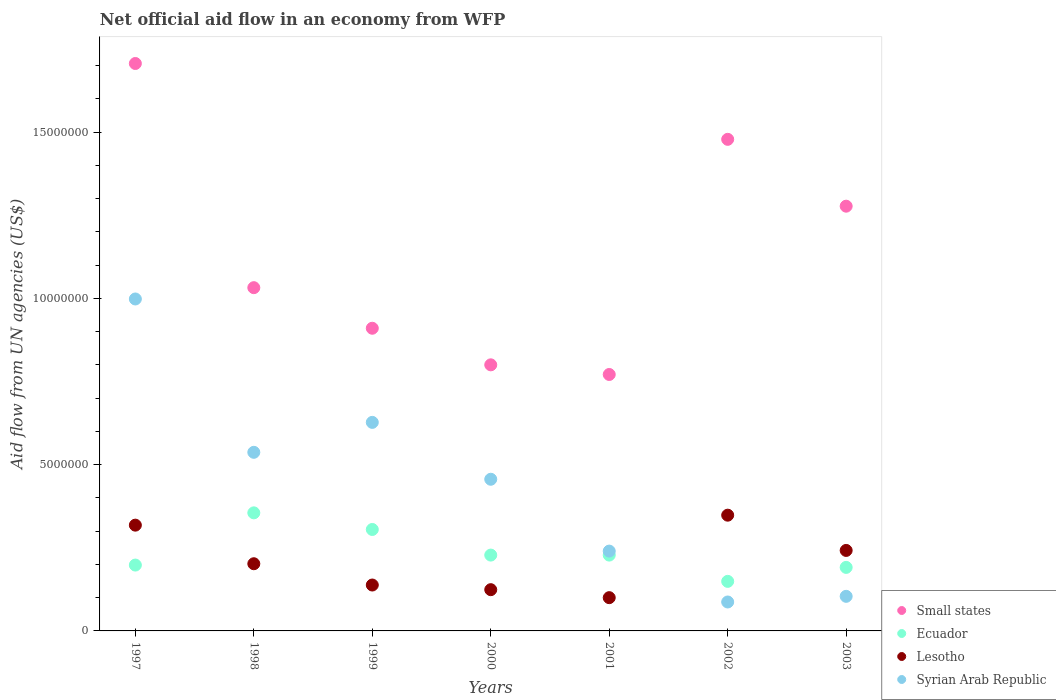How many different coloured dotlines are there?
Make the answer very short. 4. Is the number of dotlines equal to the number of legend labels?
Ensure brevity in your answer.  Yes. What is the net official aid flow in Lesotho in 2000?
Give a very brief answer. 1.24e+06. Across all years, what is the maximum net official aid flow in Small states?
Offer a terse response. 1.71e+07. Across all years, what is the minimum net official aid flow in Syrian Arab Republic?
Your answer should be very brief. 8.70e+05. What is the total net official aid flow in Ecuador in the graph?
Offer a terse response. 1.65e+07. What is the difference between the net official aid flow in Ecuador in 1998 and that in 1999?
Ensure brevity in your answer.  5.00e+05. What is the difference between the net official aid flow in Small states in 1997 and the net official aid flow in Lesotho in 2001?
Ensure brevity in your answer.  1.61e+07. What is the average net official aid flow in Syrian Arab Republic per year?
Ensure brevity in your answer.  4.36e+06. In the year 1998, what is the difference between the net official aid flow in Syrian Arab Republic and net official aid flow in Ecuador?
Offer a terse response. 1.82e+06. In how many years, is the net official aid flow in Syrian Arab Republic greater than 14000000 US$?
Ensure brevity in your answer.  0. What is the ratio of the net official aid flow in Small states in 2001 to that in 2002?
Ensure brevity in your answer.  0.52. Is the net official aid flow in Syrian Arab Republic in 1998 less than that in 2003?
Your answer should be very brief. No. Is the difference between the net official aid flow in Syrian Arab Republic in 1998 and 2000 greater than the difference between the net official aid flow in Ecuador in 1998 and 2000?
Your answer should be very brief. No. What is the difference between the highest and the second highest net official aid flow in Syrian Arab Republic?
Offer a terse response. 3.71e+06. What is the difference between the highest and the lowest net official aid flow in Ecuador?
Offer a terse response. 2.06e+06. In how many years, is the net official aid flow in Lesotho greater than the average net official aid flow in Lesotho taken over all years?
Offer a terse response. 3. Is it the case that in every year, the sum of the net official aid flow in Lesotho and net official aid flow in Ecuador  is greater than the net official aid flow in Syrian Arab Republic?
Provide a succinct answer. No. Does the net official aid flow in Syrian Arab Republic monotonically increase over the years?
Ensure brevity in your answer.  No. Is the net official aid flow in Small states strictly greater than the net official aid flow in Lesotho over the years?
Your answer should be very brief. Yes. Is the net official aid flow in Syrian Arab Republic strictly less than the net official aid flow in Ecuador over the years?
Provide a short and direct response. No. How many dotlines are there?
Offer a very short reply. 4. How many years are there in the graph?
Ensure brevity in your answer.  7. Does the graph contain grids?
Keep it short and to the point. No. What is the title of the graph?
Your answer should be compact. Net official aid flow in an economy from WFP. What is the label or title of the Y-axis?
Make the answer very short. Aid flow from UN agencies (US$). What is the Aid flow from UN agencies (US$) of Small states in 1997?
Make the answer very short. 1.71e+07. What is the Aid flow from UN agencies (US$) of Ecuador in 1997?
Offer a terse response. 1.98e+06. What is the Aid flow from UN agencies (US$) in Lesotho in 1997?
Keep it short and to the point. 3.18e+06. What is the Aid flow from UN agencies (US$) in Syrian Arab Republic in 1997?
Your answer should be very brief. 9.98e+06. What is the Aid flow from UN agencies (US$) in Small states in 1998?
Your response must be concise. 1.03e+07. What is the Aid flow from UN agencies (US$) of Ecuador in 1998?
Provide a succinct answer. 3.55e+06. What is the Aid flow from UN agencies (US$) of Lesotho in 1998?
Offer a very short reply. 2.02e+06. What is the Aid flow from UN agencies (US$) of Syrian Arab Republic in 1998?
Provide a short and direct response. 5.37e+06. What is the Aid flow from UN agencies (US$) of Small states in 1999?
Keep it short and to the point. 9.10e+06. What is the Aid flow from UN agencies (US$) of Ecuador in 1999?
Keep it short and to the point. 3.05e+06. What is the Aid flow from UN agencies (US$) of Lesotho in 1999?
Your answer should be compact. 1.38e+06. What is the Aid flow from UN agencies (US$) in Syrian Arab Republic in 1999?
Offer a terse response. 6.27e+06. What is the Aid flow from UN agencies (US$) in Ecuador in 2000?
Provide a short and direct response. 2.28e+06. What is the Aid flow from UN agencies (US$) in Lesotho in 2000?
Your answer should be compact. 1.24e+06. What is the Aid flow from UN agencies (US$) in Syrian Arab Republic in 2000?
Your answer should be very brief. 4.56e+06. What is the Aid flow from UN agencies (US$) in Small states in 2001?
Your response must be concise. 7.71e+06. What is the Aid flow from UN agencies (US$) in Ecuador in 2001?
Give a very brief answer. 2.28e+06. What is the Aid flow from UN agencies (US$) of Lesotho in 2001?
Your response must be concise. 1.00e+06. What is the Aid flow from UN agencies (US$) of Syrian Arab Republic in 2001?
Offer a very short reply. 2.40e+06. What is the Aid flow from UN agencies (US$) in Small states in 2002?
Your answer should be very brief. 1.48e+07. What is the Aid flow from UN agencies (US$) of Ecuador in 2002?
Your response must be concise. 1.49e+06. What is the Aid flow from UN agencies (US$) of Lesotho in 2002?
Provide a short and direct response. 3.48e+06. What is the Aid flow from UN agencies (US$) in Syrian Arab Republic in 2002?
Provide a succinct answer. 8.70e+05. What is the Aid flow from UN agencies (US$) of Small states in 2003?
Give a very brief answer. 1.28e+07. What is the Aid flow from UN agencies (US$) of Ecuador in 2003?
Offer a terse response. 1.91e+06. What is the Aid flow from UN agencies (US$) in Lesotho in 2003?
Make the answer very short. 2.42e+06. What is the Aid flow from UN agencies (US$) of Syrian Arab Republic in 2003?
Offer a very short reply. 1.04e+06. Across all years, what is the maximum Aid flow from UN agencies (US$) of Small states?
Give a very brief answer. 1.71e+07. Across all years, what is the maximum Aid flow from UN agencies (US$) of Ecuador?
Offer a very short reply. 3.55e+06. Across all years, what is the maximum Aid flow from UN agencies (US$) of Lesotho?
Give a very brief answer. 3.48e+06. Across all years, what is the maximum Aid flow from UN agencies (US$) of Syrian Arab Republic?
Provide a short and direct response. 9.98e+06. Across all years, what is the minimum Aid flow from UN agencies (US$) of Small states?
Provide a short and direct response. 7.71e+06. Across all years, what is the minimum Aid flow from UN agencies (US$) of Ecuador?
Provide a short and direct response. 1.49e+06. Across all years, what is the minimum Aid flow from UN agencies (US$) in Syrian Arab Republic?
Your response must be concise. 8.70e+05. What is the total Aid flow from UN agencies (US$) of Small states in the graph?
Ensure brevity in your answer.  7.97e+07. What is the total Aid flow from UN agencies (US$) in Ecuador in the graph?
Your answer should be compact. 1.65e+07. What is the total Aid flow from UN agencies (US$) in Lesotho in the graph?
Ensure brevity in your answer.  1.47e+07. What is the total Aid flow from UN agencies (US$) of Syrian Arab Republic in the graph?
Your response must be concise. 3.05e+07. What is the difference between the Aid flow from UN agencies (US$) in Small states in 1997 and that in 1998?
Your answer should be very brief. 6.74e+06. What is the difference between the Aid flow from UN agencies (US$) in Ecuador in 1997 and that in 1998?
Your answer should be compact. -1.57e+06. What is the difference between the Aid flow from UN agencies (US$) in Lesotho in 1997 and that in 1998?
Provide a short and direct response. 1.16e+06. What is the difference between the Aid flow from UN agencies (US$) of Syrian Arab Republic in 1997 and that in 1998?
Your answer should be very brief. 4.61e+06. What is the difference between the Aid flow from UN agencies (US$) in Small states in 1997 and that in 1999?
Ensure brevity in your answer.  7.96e+06. What is the difference between the Aid flow from UN agencies (US$) of Ecuador in 1997 and that in 1999?
Give a very brief answer. -1.07e+06. What is the difference between the Aid flow from UN agencies (US$) of Lesotho in 1997 and that in 1999?
Make the answer very short. 1.80e+06. What is the difference between the Aid flow from UN agencies (US$) of Syrian Arab Republic in 1997 and that in 1999?
Ensure brevity in your answer.  3.71e+06. What is the difference between the Aid flow from UN agencies (US$) of Small states in 1997 and that in 2000?
Offer a terse response. 9.06e+06. What is the difference between the Aid flow from UN agencies (US$) of Lesotho in 1997 and that in 2000?
Provide a short and direct response. 1.94e+06. What is the difference between the Aid flow from UN agencies (US$) in Syrian Arab Republic in 1997 and that in 2000?
Offer a terse response. 5.42e+06. What is the difference between the Aid flow from UN agencies (US$) in Small states in 1997 and that in 2001?
Your answer should be very brief. 9.35e+06. What is the difference between the Aid flow from UN agencies (US$) of Lesotho in 1997 and that in 2001?
Give a very brief answer. 2.18e+06. What is the difference between the Aid flow from UN agencies (US$) of Syrian Arab Republic in 1997 and that in 2001?
Provide a succinct answer. 7.58e+06. What is the difference between the Aid flow from UN agencies (US$) of Small states in 1997 and that in 2002?
Provide a succinct answer. 2.28e+06. What is the difference between the Aid flow from UN agencies (US$) in Ecuador in 1997 and that in 2002?
Ensure brevity in your answer.  4.90e+05. What is the difference between the Aid flow from UN agencies (US$) of Syrian Arab Republic in 1997 and that in 2002?
Provide a short and direct response. 9.11e+06. What is the difference between the Aid flow from UN agencies (US$) of Small states in 1997 and that in 2003?
Your answer should be compact. 4.29e+06. What is the difference between the Aid flow from UN agencies (US$) of Lesotho in 1997 and that in 2003?
Your answer should be compact. 7.60e+05. What is the difference between the Aid flow from UN agencies (US$) in Syrian Arab Republic in 1997 and that in 2003?
Your response must be concise. 8.94e+06. What is the difference between the Aid flow from UN agencies (US$) in Small states in 1998 and that in 1999?
Offer a very short reply. 1.22e+06. What is the difference between the Aid flow from UN agencies (US$) of Ecuador in 1998 and that in 1999?
Your answer should be compact. 5.00e+05. What is the difference between the Aid flow from UN agencies (US$) in Lesotho in 1998 and that in 1999?
Provide a succinct answer. 6.40e+05. What is the difference between the Aid flow from UN agencies (US$) of Syrian Arab Republic in 1998 and that in 1999?
Offer a terse response. -9.00e+05. What is the difference between the Aid flow from UN agencies (US$) of Small states in 1998 and that in 2000?
Give a very brief answer. 2.32e+06. What is the difference between the Aid flow from UN agencies (US$) in Ecuador in 1998 and that in 2000?
Make the answer very short. 1.27e+06. What is the difference between the Aid flow from UN agencies (US$) in Lesotho in 1998 and that in 2000?
Offer a very short reply. 7.80e+05. What is the difference between the Aid flow from UN agencies (US$) in Syrian Arab Republic in 1998 and that in 2000?
Offer a terse response. 8.10e+05. What is the difference between the Aid flow from UN agencies (US$) of Small states in 1998 and that in 2001?
Your answer should be very brief. 2.61e+06. What is the difference between the Aid flow from UN agencies (US$) of Ecuador in 1998 and that in 2001?
Provide a short and direct response. 1.27e+06. What is the difference between the Aid flow from UN agencies (US$) in Lesotho in 1998 and that in 2001?
Your response must be concise. 1.02e+06. What is the difference between the Aid flow from UN agencies (US$) in Syrian Arab Republic in 1998 and that in 2001?
Offer a very short reply. 2.97e+06. What is the difference between the Aid flow from UN agencies (US$) in Small states in 1998 and that in 2002?
Provide a short and direct response. -4.46e+06. What is the difference between the Aid flow from UN agencies (US$) of Ecuador in 1998 and that in 2002?
Provide a short and direct response. 2.06e+06. What is the difference between the Aid flow from UN agencies (US$) in Lesotho in 1998 and that in 2002?
Provide a succinct answer. -1.46e+06. What is the difference between the Aid flow from UN agencies (US$) of Syrian Arab Republic in 1998 and that in 2002?
Your answer should be compact. 4.50e+06. What is the difference between the Aid flow from UN agencies (US$) in Small states in 1998 and that in 2003?
Your response must be concise. -2.45e+06. What is the difference between the Aid flow from UN agencies (US$) in Ecuador in 1998 and that in 2003?
Your answer should be very brief. 1.64e+06. What is the difference between the Aid flow from UN agencies (US$) of Lesotho in 1998 and that in 2003?
Make the answer very short. -4.00e+05. What is the difference between the Aid flow from UN agencies (US$) in Syrian Arab Republic in 1998 and that in 2003?
Ensure brevity in your answer.  4.33e+06. What is the difference between the Aid flow from UN agencies (US$) in Small states in 1999 and that in 2000?
Keep it short and to the point. 1.10e+06. What is the difference between the Aid flow from UN agencies (US$) in Ecuador in 1999 and that in 2000?
Provide a short and direct response. 7.70e+05. What is the difference between the Aid flow from UN agencies (US$) of Lesotho in 1999 and that in 2000?
Your answer should be compact. 1.40e+05. What is the difference between the Aid flow from UN agencies (US$) in Syrian Arab Republic in 1999 and that in 2000?
Ensure brevity in your answer.  1.71e+06. What is the difference between the Aid flow from UN agencies (US$) in Small states in 1999 and that in 2001?
Provide a succinct answer. 1.39e+06. What is the difference between the Aid flow from UN agencies (US$) of Ecuador in 1999 and that in 2001?
Provide a short and direct response. 7.70e+05. What is the difference between the Aid flow from UN agencies (US$) of Lesotho in 1999 and that in 2001?
Offer a very short reply. 3.80e+05. What is the difference between the Aid flow from UN agencies (US$) in Syrian Arab Republic in 1999 and that in 2001?
Your answer should be compact. 3.87e+06. What is the difference between the Aid flow from UN agencies (US$) in Small states in 1999 and that in 2002?
Your answer should be very brief. -5.68e+06. What is the difference between the Aid flow from UN agencies (US$) of Ecuador in 1999 and that in 2002?
Give a very brief answer. 1.56e+06. What is the difference between the Aid flow from UN agencies (US$) of Lesotho in 1999 and that in 2002?
Give a very brief answer. -2.10e+06. What is the difference between the Aid flow from UN agencies (US$) in Syrian Arab Republic in 1999 and that in 2002?
Your answer should be compact. 5.40e+06. What is the difference between the Aid flow from UN agencies (US$) in Small states in 1999 and that in 2003?
Your response must be concise. -3.67e+06. What is the difference between the Aid flow from UN agencies (US$) in Ecuador in 1999 and that in 2003?
Your response must be concise. 1.14e+06. What is the difference between the Aid flow from UN agencies (US$) in Lesotho in 1999 and that in 2003?
Your response must be concise. -1.04e+06. What is the difference between the Aid flow from UN agencies (US$) in Syrian Arab Republic in 1999 and that in 2003?
Make the answer very short. 5.23e+06. What is the difference between the Aid flow from UN agencies (US$) of Lesotho in 2000 and that in 2001?
Ensure brevity in your answer.  2.40e+05. What is the difference between the Aid flow from UN agencies (US$) in Syrian Arab Republic in 2000 and that in 2001?
Provide a succinct answer. 2.16e+06. What is the difference between the Aid flow from UN agencies (US$) in Small states in 2000 and that in 2002?
Make the answer very short. -6.78e+06. What is the difference between the Aid flow from UN agencies (US$) in Ecuador in 2000 and that in 2002?
Your answer should be very brief. 7.90e+05. What is the difference between the Aid flow from UN agencies (US$) in Lesotho in 2000 and that in 2002?
Offer a terse response. -2.24e+06. What is the difference between the Aid flow from UN agencies (US$) of Syrian Arab Republic in 2000 and that in 2002?
Your answer should be very brief. 3.69e+06. What is the difference between the Aid flow from UN agencies (US$) in Small states in 2000 and that in 2003?
Ensure brevity in your answer.  -4.77e+06. What is the difference between the Aid flow from UN agencies (US$) of Ecuador in 2000 and that in 2003?
Your answer should be compact. 3.70e+05. What is the difference between the Aid flow from UN agencies (US$) in Lesotho in 2000 and that in 2003?
Provide a short and direct response. -1.18e+06. What is the difference between the Aid flow from UN agencies (US$) in Syrian Arab Republic in 2000 and that in 2003?
Your answer should be very brief. 3.52e+06. What is the difference between the Aid flow from UN agencies (US$) of Small states in 2001 and that in 2002?
Offer a very short reply. -7.07e+06. What is the difference between the Aid flow from UN agencies (US$) of Ecuador in 2001 and that in 2002?
Provide a succinct answer. 7.90e+05. What is the difference between the Aid flow from UN agencies (US$) in Lesotho in 2001 and that in 2002?
Offer a terse response. -2.48e+06. What is the difference between the Aid flow from UN agencies (US$) in Syrian Arab Republic in 2001 and that in 2002?
Your response must be concise. 1.53e+06. What is the difference between the Aid flow from UN agencies (US$) in Small states in 2001 and that in 2003?
Give a very brief answer. -5.06e+06. What is the difference between the Aid flow from UN agencies (US$) in Ecuador in 2001 and that in 2003?
Provide a succinct answer. 3.70e+05. What is the difference between the Aid flow from UN agencies (US$) in Lesotho in 2001 and that in 2003?
Provide a short and direct response. -1.42e+06. What is the difference between the Aid flow from UN agencies (US$) of Syrian Arab Republic in 2001 and that in 2003?
Your response must be concise. 1.36e+06. What is the difference between the Aid flow from UN agencies (US$) of Small states in 2002 and that in 2003?
Your response must be concise. 2.01e+06. What is the difference between the Aid flow from UN agencies (US$) of Ecuador in 2002 and that in 2003?
Your response must be concise. -4.20e+05. What is the difference between the Aid flow from UN agencies (US$) in Lesotho in 2002 and that in 2003?
Your response must be concise. 1.06e+06. What is the difference between the Aid flow from UN agencies (US$) in Syrian Arab Republic in 2002 and that in 2003?
Provide a succinct answer. -1.70e+05. What is the difference between the Aid flow from UN agencies (US$) in Small states in 1997 and the Aid flow from UN agencies (US$) in Ecuador in 1998?
Provide a succinct answer. 1.35e+07. What is the difference between the Aid flow from UN agencies (US$) in Small states in 1997 and the Aid flow from UN agencies (US$) in Lesotho in 1998?
Your answer should be compact. 1.50e+07. What is the difference between the Aid flow from UN agencies (US$) in Small states in 1997 and the Aid flow from UN agencies (US$) in Syrian Arab Republic in 1998?
Your response must be concise. 1.17e+07. What is the difference between the Aid flow from UN agencies (US$) of Ecuador in 1997 and the Aid flow from UN agencies (US$) of Syrian Arab Republic in 1998?
Provide a succinct answer. -3.39e+06. What is the difference between the Aid flow from UN agencies (US$) of Lesotho in 1997 and the Aid flow from UN agencies (US$) of Syrian Arab Republic in 1998?
Offer a terse response. -2.19e+06. What is the difference between the Aid flow from UN agencies (US$) of Small states in 1997 and the Aid flow from UN agencies (US$) of Ecuador in 1999?
Offer a very short reply. 1.40e+07. What is the difference between the Aid flow from UN agencies (US$) in Small states in 1997 and the Aid flow from UN agencies (US$) in Lesotho in 1999?
Give a very brief answer. 1.57e+07. What is the difference between the Aid flow from UN agencies (US$) of Small states in 1997 and the Aid flow from UN agencies (US$) of Syrian Arab Republic in 1999?
Your answer should be compact. 1.08e+07. What is the difference between the Aid flow from UN agencies (US$) in Ecuador in 1997 and the Aid flow from UN agencies (US$) in Lesotho in 1999?
Your response must be concise. 6.00e+05. What is the difference between the Aid flow from UN agencies (US$) in Ecuador in 1997 and the Aid flow from UN agencies (US$) in Syrian Arab Republic in 1999?
Your response must be concise. -4.29e+06. What is the difference between the Aid flow from UN agencies (US$) of Lesotho in 1997 and the Aid flow from UN agencies (US$) of Syrian Arab Republic in 1999?
Ensure brevity in your answer.  -3.09e+06. What is the difference between the Aid flow from UN agencies (US$) of Small states in 1997 and the Aid flow from UN agencies (US$) of Ecuador in 2000?
Provide a succinct answer. 1.48e+07. What is the difference between the Aid flow from UN agencies (US$) of Small states in 1997 and the Aid flow from UN agencies (US$) of Lesotho in 2000?
Your answer should be compact. 1.58e+07. What is the difference between the Aid flow from UN agencies (US$) in Small states in 1997 and the Aid flow from UN agencies (US$) in Syrian Arab Republic in 2000?
Make the answer very short. 1.25e+07. What is the difference between the Aid flow from UN agencies (US$) in Ecuador in 1997 and the Aid flow from UN agencies (US$) in Lesotho in 2000?
Provide a short and direct response. 7.40e+05. What is the difference between the Aid flow from UN agencies (US$) in Ecuador in 1997 and the Aid flow from UN agencies (US$) in Syrian Arab Republic in 2000?
Make the answer very short. -2.58e+06. What is the difference between the Aid flow from UN agencies (US$) of Lesotho in 1997 and the Aid flow from UN agencies (US$) of Syrian Arab Republic in 2000?
Provide a short and direct response. -1.38e+06. What is the difference between the Aid flow from UN agencies (US$) of Small states in 1997 and the Aid flow from UN agencies (US$) of Ecuador in 2001?
Your answer should be compact. 1.48e+07. What is the difference between the Aid flow from UN agencies (US$) of Small states in 1997 and the Aid flow from UN agencies (US$) of Lesotho in 2001?
Offer a terse response. 1.61e+07. What is the difference between the Aid flow from UN agencies (US$) in Small states in 1997 and the Aid flow from UN agencies (US$) in Syrian Arab Republic in 2001?
Your answer should be compact. 1.47e+07. What is the difference between the Aid flow from UN agencies (US$) in Ecuador in 1997 and the Aid flow from UN agencies (US$) in Lesotho in 2001?
Ensure brevity in your answer.  9.80e+05. What is the difference between the Aid flow from UN agencies (US$) in Ecuador in 1997 and the Aid flow from UN agencies (US$) in Syrian Arab Republic in 2001?
Your answer should be very brief. -4.20e+05. What is the difference between the Aid flow from UN agencies (US$) of Lesotho in 1997 and the Aid flow from UN agencies (US$) of Syrian Arab Republic in 2001?
Make the answer very short. 7.80e+05. What is the difference between the Aid flow from UN agencies (US$) in Small states in 1997 and the Aid flow from UN agencies (US$) in Ecuador in 2002?
Provide a succinct answer. 1.56e+07. What is the difference between the Aid flow from UN agencies (US$) of Small states in 1997 and the Aid flow from UN agencies (US$) of Lesotho in 2002?
Keep it short and to the point. 1.36e+07. What is the difference between the Aid flow from UN agencies (US$) in Small states in 1997 and the Aid flow from UN agencies (US$) in Syrian Arab Republic in 2002?
Your answer should be very brief. 1.62e+07. What is the difference between the Aid flow from UN agencies (US$) of Ecuador in 1997 and the Aid flow from UN agencies (US$) of Lesotho in 2002?
Provide a succinct answer. -1.50e+06. What is the difference between the Aid flow from UN agencies (US$) in Ecuador in 1997 and the Aid flow from UN agencies (US$) in Syrian Arab Republic in 2002?
Keep it short and to the point. 1.11e+06. What is the difference between the Aid flow from UN agencies (US$) in Lesotho in 1997 and the Aid flow from UN agencies (US$) in Syrian Arab Republic in 2002?
Offer a very short reply. 2.31e+06. What is the difference between the Aid flow from UN agencies (US$) in Small states in 1997 and the Aid flow from UN agencies (US$) in Ecuador in 2003?
Give a very brief answer. 1.52e+07. What is the difference between the Aid flow from UN agencies (US$) of Small states in 1997 and the Aid flow from UN agencies (US$) of Lesotho in 2003?
Provide a succinct answer. 1.46e+07. What is the difference between the Aid flow from UN agencies (US$) in Small states in 1997 and the Aid flow from UN agencies (US$) in Syrian Arab Republic in 2003?
Offer a terse response. 1.60e+07. What is the difference between the Aid flow from UN agencies (US$) of Ecuador in 1997 and the Aid flow from UN agencies (US$) of Lesotho in 2003?
Keep it short and to the point. -4.40e+05. What is the difference between the Aid flow from UN agencies (US$) of Ecuador in 1997 and the Aid flow from UN agencies (US$) of Syrian Arab Republic in 2003?
Give a very brief answer. 9.40e+05. What is the difference between the Aid flow from UN agencies (US$) of Lesotho in 1997 and the Aid flow from UN agencies (US$) of Syrian Arab Republic in 2003?
Your answer should be very brief. 2.14e+06. What is the difference between the Aid flow from UN agencies (US$) of Small states in 1998 and the Aid flow from UN agencies (US$) of Ecuador in 1999?
Keep it short and to the point. 7.27e+06. What is the difference between the Aid flow from UN agencies (US$) in Small states in 1998 and the Aid flow from UN agencies (US$) in Lesotho in 1999?
Your answer should be very brief. 8.94e+06. What is the difference between the Aid flow from UN agencies (US$) of Small states in 1998 and the Aid flow from UN agencies (US$) of Syrian Arab Republic in 1999?
Provide a succinct answer. 4.05e+06. What is the difference between the Aid flow from UN agencies (US$) in Ecuador in 1998 and the Aid flow from UN agencies (US$) in Lesotho in 1999?
Provide a short and direct response. 2.17e+06. What is the difference between the Aid flow from UN agencies (US$) of Ecuador in 1998 and the Aid flow from UN agencies (US$) of Syrian Arab Republic in 1999?
Provide a short and direct response. -2.72e+06. What is the difference between the Aid flow from UN agencies (US$) in Lesotho in 1998 and the Aid flow from UN agencies (US$) in Syrian Arab Republic in 1999?
Keep it short and to the point. -4.25e+06. What is the difference between the Aid flow from UN agencies (US$) in Small states in 1998 and the Aid flow from UN agencies (US$) in Ecuador in 2000?
Make the answer very short. 8.04e+06. What is the difference between the Aid flow from UN agencies (US$) in Small states in 1998 and the Aid flow from UN agencies (US$) in Lesotho in 2000?
Give a very brief answer. 9.08e+06. What is the difference between the Aid flow from UN agencies (US$) of Small states in 1998 and the Aid flow from UN agencies (US$) of Syrian Arab Republic in 2000?
Make the answer very short. 5.76e+06. What is the difference between the Aid flow from UN agencies (US$) in Ecuador in 1998 and the Aid flow from UN agencies (US$) in Lesotho in 2000?
Make the answer very short. 2.31e+06. What is the difference between the Aid flow from UN agencies (US$) of Ecuador in 1998 and the Aid flow from UN agencies (US$) of Syrian Arab Republic in 2000?
Your response must be concise. -1.01e+06. What is the difference between the Aid flow from UN agencies (US$) of Lesotho in 1998 and the Aid flow from UN agencies (US$) of Syrian Arab Republic in 2000?
Your answer should be very brief. -2.54e+06. What is the difference between the Aid flow from UN agencies (US$) of Small states in 1998 and the Aid flow from UN agencies (US$) of Ecuador in 2001?
Give a very brief answer. 8.04e+06. What is the difference between the Aid flow from UN agencies (US$) of Small states in 1998 and the Aid flow from UN agencies (US$) of Lesotho in 2001?
Your answer should be compact. 9.32e+06. What is the difference between the Aid flow from UN agencies (US$) of Small states in 1998 and the Aid flow from UN agencies (US$) of Syrian Arab Republic in 2001?
Keep it short and to the point. 7.92e+06. What is the difference between the Aid flow from UN agencies (US$) in Ecuador in 1998 and the Aid flow from UN agencies (US$) in Lesotho in 2001?
Your response must be concise. 2.55e+06. What is the difference between the Aid flow from UN agencies (US$) of Ecuador in 1998 and the Aid flow from UN agencies (US$) of Syrian Arab Republic in 2001?
Your answer should be very brief. 1.15e+06. What is the difference between the Aid flow from UN agencies (US$) of Lesotho in 1998 and the Aid flow from UN agencies (US$) of Syrian Arab Republic in 2001?
Keep it short and to the point. -3.80e+05. What is the difference between the Aid flow from UN agencies (US$) of Small states in 1998 and the Aid flow from UN agencies (US$) of Ecuador in 2002?
Provide a succinct answer. 8.83e+06. What is the difference between the Aid flow from UN agencies (US$) of Small states in 1998 and the Aid flow from UN agencies (US$) of Lesotho in 2002?
Your answer should be compact. 6.84e+06. What is the difference between the Aid flow from UN agencies (US$) in Small states in 1998 and the Aid flow from UN agencies (US$) in Syrian Arab Republic in 2002?
Keep it short and to the point. 9.45e+06. What is the difference between the Aid flow from UN agencies (US$) in Ecuador in 1998 and the Aid flow from UN agencies (US$) in Lesotho in 2002?
Provide a succinct answer. 7.00e+04. What is the difference between the Aid flow from UN agencies (US$) in Ecuador in 1998 and the Aid flow from UN agencies (US$) in Syrian Arab Republic in 2002?
Your response must be concise. 2.68e+06. What is the difference between the Aid flow from UN agencies (US$) in Lesotho in 1998 and the Aid flow from UN agencies (US$) in Syrian Arab Republic in 2002?
Ensure brevity in your answer.  1.15e+06. What is the difference between the Aid flow from UN agencies (US$) in Small states in 1998 and the Aid flow from UN agencies (US$) in Ecuador in 2003?
Your answer should be compact. 8.41e+06. What is the difference between the Aid flow from UN agencies (US$) of Small states in 1998 and the Aid flow from UN agencies (US$) of Lesotho in 2003?
Keep it short and to the point. 7.90e+06. What is the difference between the Aid flow from UN agencies (US$) in Small states in 1998 and the Aid flow from UN agencies (US$) in Syrian Arab Republic in 2003?
Provide a short and direct response. 9.28e+06. What is the difference between the Aid flow from UN agencies (US$) of Ecuador in 1998 and the Aid flow from UN agencies (US$) of Lesotho in 2003?
Give a very brief answer. 1.13e+06. What is the difference between the Aid flow from UN agencies (US$) of Ecuador in 1998 and the Aid flow from UN agencies (US$) of Syrian Arab Republic in 2003?
Keep it short and to the point. 2.51e+06. What is the difference between the Aid flow from UN agencies (US$) in Lesotho in 1998 and the Aid flow from UN agencies (US$) in Syrian Arab Republic in 2003?
Your response must be concise. 9.80e+05. What is the difference between the Aid flow from UN agencies (US$) of Small states in 1999 and the Aid flow from UN agencies (US$) of Ecuador in 2000?
Offer a terse response. 6.82e+06. What is the difference between the Aid flow from UN agencies (US$) in Small states in 1999 and the Aid flow from UN agencies (US$) in Lesotho in 2000?
Your response must be concise. 7.86e+06. What is the difference between the Aid flow from UN agencies (US$) of Small states in 1999 and the Aid flow from UN agencies (US$) of Syrian Arab Republic in 2000?
Your answer should be very brief. 4.54e+06. What is the difference between the Aid flow from UN agencies (US$) of Ecuador in 1999 and the Aid flow from UN agencies (US$) of Lesotho in 2000?
Offer a terse response. 1.81e+06. What is the difference between the Aid flow from UN agencies (US$) of Ecuador in 1999 and the Aid flow from UN agencies (US$) of Syrian Arab Republic in 2000?
Give a very brief answer. -1.51e+06. What is the difference between the Aid flow from UN agencies (US$) in Lesotho in 1999 and the Aid flow from UN agencies (US$) in Syrian Arab Republic in 2000?
Provide a short and direct response. -3.18e+06. What is the difference between the Aid flow from UN agencies (US$) in Small states in 1999 and the Aid flow from UN agencies (US$) in Ecuador in 2001?
Offer a terse response. 6.82e+06. What is the difference between the Aid flow from UN agencies (US$) of Small states in 1999 and the Aid flow from UN agencies (US$) of Lesotho in 2001?
Keep it short and to the point. 8.10e+06. What is the difference between the Aid flow from UN agencies (US$) in Small states in 1999 and the Aid flow from UN agencies (US$) in Syrian Arab Republic in 2001?
Your answer should be compact. 6.70e+06. What is the difference between the Aid flow from UN agencies (US$) of Ecuador in 1999 and the Aid flow from UN agencies (US$) of Lesotho in 2001?
Your response must be concise. 2.05e+06. What is the difference between the Aid flow from UN agencies (US$) in Ecuador in 1999 and the Aid flow from UN agencies (US$) in Syrian Arab Republic in 2001?
Ensure brevity in your answer.  6.50e+05. What is the difference between the Aid flow from UN agencies (US$) in Lesotho in 1999 and the Aid flow from UN agencies (US$) in Syrian Arab Republic in 2001?
Your response must be concise. -1.02e+06. What is the difference between the Aid flow from UN agencies (US$) in Small states in 1999 and the Aid flow from UN agencies (US$) in Ecuador in 2002?
Keep it short and to the point. 7.61e+06. What is the difference between the Aid flow from UN agencies (US$) of Small states in 1999 and the Aid flow from UN agencies (US$) of Lesotho in 2002?
Provide a short and direct response. 5.62e+06. What is the difference between the Aid flow from UN agencies (US$) in Small states in 1999 and the Aid flow from UN agencies (US$) in Syrian Arab Republic in 2002?
Ensure brevity in your answer.  8.23e+06. What is the difference between the Aid flow from UN agencies (US$) of Ecuador in 1999 and the Aid flow from UN agencies (US$) of Lesotho in 2002?
Offer a very short reply. -4.30e+05. What is the difference between the Aid flow from UN agencies (US$) in Ecuador in 1999 and the Aid flow from UN agencies (US$) in Syrian Arab Republic in 2002?
Your answer should be compact. 2.18e+06. What is the difference between the Aid flow from UN agencies (US$) of Lesotho in 1999 and the Aid flow from UN agencies (US$) of Syrian Arab Republic in 2002?
Offer a very short reply. 5.10e+05. What is the difference between the Aid flow from UN agencies (US$) of Small states in 1999 and the Aid flow from UN agencies (US$) of Ecuador in 2003?
Keep it short and to the point. 7.19e+06. What is the difference between the Aid flow from UN agencies (US$) of Small states in 1999 and the Aid flow from UN agencies (US$) of Lesotho in 2003?
Your answer should be compact. 6.68e+06. What is the difference between the Aid flow from UN agencies (US$) of Small states in 1999 and the Aid flow from UN agencies (US$) of Syrian Arab Republic in 2003?
Ensure brevity in your answer.  8.06e+06. What is the difference between the Aid flow from UN agencies (US$) in Ecuador in 1999 and the Aid flow from UN agencies (US$) in Lesotho in 2003?
Give a very brief answer. 6.30e+05. What is the difference between the Aid flow from UN agencies (US$) of Ecuador in 1999 and the Aid flow from UN agencies (US$) of Syrian Arab Republic in 2003?
Your response must be concise. 2.01e+06. What is the difference between the Aid flow from UN agencies (US$) of Lesotho in 1999 and the Aid flow from UN agencies (US$) of Syrian Arab Republic in 2003?
Give a very brief answer. 3.40e+05. What is the difference between the Aid flow from UN agencies (US$) in Small states in 2000 and the Aid flow from UN agencies (US$) in Ecuador in 2001?
Make the answer very short. 5.72e+06. What is the difference between the Aid flow from UN agencies (US$) of Small states in 2000 and the Aid flow from UN agencies (US$) of Syrian Arab Republic in 2001?
Your response must be concise. 5.60e+06. What is the difference between the Aid flow from UN agencies (US$) of Ecuador in 2000 and the Aid flow from UN agencies (US$) of Lesotho in 2001?
Your response must be concise. 1.28e+06. What is the difference between the Aid flow from UN agencies (US$) of Ecuador in 2000 and the Aid flow from UN agencies (US$) of Syrian Arab Republic in 2001?
Your response must be concise. -1.20e+05. What is the difference between the Aid flow from UN agencies (US$) in Lesotho in 2000 and the Aid flow from UN agencies (US$) in Syrian Arab Republic in 2001?
Your answer should be compact. -1.16e+06. What is the difference between the Aid flow from UN agencies (US$) in Small states in 2000 and the Aid flow from UN agencies (US$) in Ecuador in 2002?
Provide a succinct answer. 6.51e+06. What is the difference between the Aid flow from UN agencies (US$) in Small states in 2000 and the Aid flow from UN agencies (US$) in Lesotho in 2002?
Offer a terse response. 4.52e+06. What is the difference between the Aid flow from UN agencies (US$) in Small states in 2000 and the Aid flow from UN agencies (US$) in Syrian Arab Republic in 2002?
Your response must be concise. 7.13e+06. What is the difference between the Aid flow from UN agencies (US$) in Ecuador in 2000 and the Aid flow from UN agencies (US$) in Lesotho in 2002?
Your answer should be very brief. -1.20e+06. What is the difference between the Aid flow from UN agencies (US$) in Ecuador in 2000 and the Aid flow from UN agencies (US$) in Syrian Arab Republic in 2002?
Offer a very short reply. 1.41e+06. What is the difference between the Aid flow from UN agencies (US$) of Small states in 2000 and the Aid flow from UN agencies (US$) of Ecuador in 2003?
Ensure brevity in your answer.  6.09e+06. What is the difference between the Aid flow from UN agencies (US$) in Small states in 2000 and the Aid flow from UN agencies (US$) in Lesotho in 2003?
Your answer should be compact. 5.58e+06. What is the difference between the Aid flow from UN agencies (US$) of Small states in 2000 and the Aid flow from UN agencies (US$) of Syrian Arab Republic in 2003?
Offer a very short reply. 6.96e+06. What is the difference between the Aid flow from UN agencies (US$) in Ecuador in 2000 and the Aid flow from UN agencies (US$) in Syrian Arab Republic in 2003?
Ensure brevity in your answer.  1.24e+06. What is the difference between the Aid flow from UN agencies (US$) in Small states in 2001 and the Aid flow from UN agencies (US$) in Ecuador in 2002?
Your answer should be compact. 6.22e+06. What is the difference between the Aid flow from UN agencies (US$) of Small states in 2001 and the Aid flow from UN agencies (US$) of Lesotho in 2002?
Your answer should be compact. 4.23e+06. What is the difference between the Aid flow from UN agencies (US$) of Small states in 2001 and the Aid flow from UN agencies (US$) of Syrian Arab Republic in 2002?
Ensure brevity in your answer.  6.84e+06. What is the difference between the Aid flow from UN agencies (US$) in Ecuador in 2001 and the Aid flow from UN agencies (US$) in Lesotho in 2002?
Offer a terse response. -1.20e+06. What is the difference between the Aid flow from UN agencies (US$) of Ecuador in 2001 and the Aid flow from UN agencies (US$) of Syrian Arab Republic in 2002?
Provide a succinct answer. 1.41e+06. What is the difference between the Aid flow from UN agencies (US$) of Lesotho in 2001 and the Aid flow from UN agencies (US$) of Syrian Arab Republic in 2002?
Your answer should be very brief. 1.30e+05. What is the difference between the Aid flow from UN agencies (US$) in Small states in 2001 and the Aid flow from UN agencies (US$) in Ecuador in 2003?
Keep it short and to the point. 5.80e+06. What is the difference between the Aid flow from UN agencies (US$) in Small states in 2001 and the Aid flow from UN agencies (US$) in Lesotho in 2003?
Offer a terse response. 5.29e+06. What is the difference between the Aid flow from UN agencies (US$) of Small states in 2001 and the Aid flow from UN agencies (US$) of Syrian Arab Republic in 2003?
Your answer should be very brief. 6.67e+06. What is the difference between the Aid flow from UN agencies (US$) of Ecuador in 2001 and the Aid flow from UN agencies (US$) of Syrian Arab Republic in 2003?
Your response must be concise. 1.24e+06. What is the difference between the Aid flow from UN agencies (US$) in Lesotho in 2001 and the Aid flow from UN agencies (US$) in Syrian Arab Republic in 2003?
Provide a short and direct response. -4.00e+04. What is the difference between the Aid flow from UN agencies (US$) of Small states in 2002 and the Aid flow from UN agencies (US$) of Ecuador in 2003?
Provide a short and direct response. 1.29e+07. What is the difference between the Aid flow from UN agencies (US$) in Small states in 2002 and the Aid flow from UN agencies (US$) in Lesotho in 2003?
Your response must be concise. 1.24e+07. What is the difference between the Aid flow from UN agencies (US$) of Small states in 2002 and the Aid flow from UN agencies (US$) of Syrian Arab Republic in 2003?
Offer a very short reply. 1.37e+07. What is the difference between the Aid flow from UN agencies (US$) of Ecuador in 2002 and the Aid flow from UN agencies (US$) of Lesotho in 2003?
Offer a terse response. -9.30e+05. What is the difference between the Aid flow from UN agencies (US$) in Ecuador in 2002 and the Aid flow from UN agencies (US$) in Syrian Arab Republic in 2003?
Give a very brief answer. 4.50e+05. What is the difference between the Aid flow from UN agencies (US$) in Lesotho in 2002 and the Aid flow from UN agencies (US$) in Syrian Arab Republic in 2003?
Provide a short and direct response. 2.44e+06. What is the average Aid flow from UN agencies (US$) in Small states per year?
Your response must be concise. 1.14e+07. What is the average Aid flow from UN agencies (US$) of Ecuador per year?
Offer a very short reply. 2.36e+06. What is the average Aid flow from UN agencies (US$) in Lesotho per year?
Make the answer very short. 2.10e+06. What is the average Aid flow from UN agencies (US$) of Syrian Arab Republic per year?
Your response must be concise. 4.36e+06. In the year 1997, what is the difference between the Aid flow from UN agencies (US$) in Small states and Aid flow from UN agencies (US$) in Ecuador?
Provide a short and direct response. 1.51e+07. In the year 1997, what is the difference between the Aid flow from UN agencies (US$) in Small states and Aid flow from UN agencies (US$) in Lesotho?
Keep it short and to the point. 1.39e+07. In the year 1997, what is the difference between the Aid flow from UN agencies (US$) in Small states and Aid flow from UN agencies (US$) in Syrian Arab Republic?
Offer a very short reply. 7.08e+06. In the year 1997, what is the difference between the Aid flow from UN agencies (US$) in Ecuador and Aid flow from UN agencies (US$) in Lesotho?
Make the answer very short. -1.20e+06. In the year 1997, what is the difference between the Aid flow from UN agencies (US$) in Ecuador and Aid flow from UN agencies (US$) in Syrian Arab Republic?
Ensure brevity in your answer.  -8.00e+06. In the year 1997, what is the difference between the Aid flow from UN agencies (US$) of Lesotho and Aid flow from UN agencies (US$) of Syrian Arab Republic?
Make the answer very short. -6.80e+06. In the year 1998, what is the difference between the Aid flow from UN agencies (US$) in Small states and Aid flow from UN agencies (US$) in Ecuador?
Give a very brief answer. 6.77e+06. In the year 1998, what is the difference between the Aid flow from UN agencies (US$) in Small states and Aid flow from UN agencies (US$) in Lesotho?
Offer a very short reply. 8.30e+06. In the year 1998, what is the difference between the Aid flow from UN agencies (US$) in Small states and Aid flow from UN agencies (US$) in Syrian Arab Republic?
Provide a succinct answer. 4.95e+06. In the year 1998, what is the difference between the Aid flow from UN agencies (US$) in Ecuador and Aid flow from UN agencies (US$) in Lesotho?
Your response must be concise. 1.53e+06. In the year 1998, what is the difference between the Aid flow from UN agencies (US$) of Ecuador and Aid flow from UN agencies (US$) of Syrian Arab Republic?
Make the answer very short. -1.82e+06. In the year 1998, what is the difference between the Aid flow from UN agencies (US$) of Lesotho and Aid flow from UN agencies (US$) of Syrian Arab Republic?
Ensure brevity in your answer.  -3.35e+06. In the year 1999, what is the difference between the Aid flow from UN agencies (US$) in Small states and Aid flow from UN agencies (US$) in Ecuador?
Provide a succinct answer. 6.05e+06. In the year 1999, what is the difference between the Aid flow from UN agencies (US$) of Small states and Aid flow from UN agencies (US$) of Lesotho?
Keep it short and to the point. 7.72e+06. In the year 1999, what is the difference between the Aid flow from UN agencies (US$) in Small states and Aid flow from UN agencies (US$) in Syrian Arab Republic?
Provide a succinct answer. 2.83e+06. In the year 1999, what is the difference between the Aid flow from UN agencies (US$) of Ecuador and Aid flow from UN agencies (US$) of Lesotho?
Provide a short and direct response. 1.67e+06. In the year 1999, what is the difference between the Aid flow from UN agencies (US$) in Ecuador and Aid flow from UN agencies (US$) in Syrian Arab Republic?
Keep it short and to the point. -3.22e+06. In the year 1999, what is the difference between the Aid flow from UN agencies (US$) in Lesotho and Aid flow from UN agencies (US$) in Syrian Arab Republic?
Your answer should be compact. -4.89e+06. In the year 2000, what is the difference between the Aid flow from UN agencies (US$) in Small states and Aid flow from UN agencies (US$) in Ecuador?
Offer a terse response. 5.72e+06. In the year 2000, what is the difference between the Aid flow from UN agencies (US$) in Small states and Aid flow from UN agencies (US$) in Lesotho?
Offer a very short reply. 6.76e+06. In the year 2000, what is the difference between the Aid flow from UN agencies (US$) of Small states and Aid flow from UN agencies (US$) of Syrian Arab Republic?
Give a very brief answer. 3.44e+06. In the year 2000, what is the difference between the Aid flow from UN agencies (US$) in Ecuador and Aid flow from UN agencies (US$) in Lesotho?
Make the answer very short. 1.04e+06. In the year 2000, what is the difference between the Aid flow from UN agencies (US$) of Ecuador and Aid flow from UN agencies (US$) of Syrian Arab Republic?
Your answer should be very brief. -2.28e+06. In the year 2000, what is the difference between the Aid flow from UN agencies (US$) in Lesotho and Aid flow from UN agencies (US$) in Syrian Arab Republic?
Your response must be concise. -3.32e+06. In the year 2001, what is the difference between the Aid flow from UN agencies (US$) of Small states and Aid flow from UN agencies (US$) of Ecuador?
Provide a succinct answer. 5.43e+06. In the year 2001, what is the difference between the Aid flow from UN agencies (US$) of Small states and Aid flow from UN agencies (US$) of Lesotho?
Provide a short and direct response. 6.71e+06. In the year 2001, what is the difference between the Aid flow from UN agencies (US$) in Small states and Aid flow from UN agencies (US$) in Syrian Arab Republic?
Provide a short and direct response. 5.31e+06. In the year 2001, what is the difference between the Aid flow from UN agencies (US$) in Ecuador and Aid flow from UN agencies (US$) in Lesotho?
Your answer should be very brief. 1.28e+06. In the year 2001, what is the difference between the Aid flow from UN agencies (US$) of Lesotho and Aid flow from UN agencies (US$) of Syrian Arab Republic?
Provide a short and direct response. -1.40e+06. In the year 2002, what is the difference between the Aid flow from UN agencies (US$) of Small states and Aid flow from UN agencies (US$) of Ecuador?
Provide a short and direct response. 1.33e+07. In the year 2002, what is the difference between the Aid flow from UN agencies (US$) in Small states and Aid flow from UN agencies (US$) in Lesotho?
Ensure brevity in your answer.  1.13e+07. In the year 2002, what is the difference between the Aid flow from UN agencies (US$) of Small states and Aid flow from UN agencies (US$) of Syrian Arab Republic?
Provide a succinct answer. 1.39e+07. In the year 2002, what is the difference between the Aid flow from UN agencies (US$) of Ecuador and Aid flow from UN agencies (US$) of Lesotho?
Offer a very short reply. -1.99e+06. In the year 2002, what is the difference between the Aid flow from UN agencies (US$) in Ecuador and Aid flow from UN agencies (US$) in Syrian Arab Republic?
Your response must be concise. 6.20e+05. In the year 2002, what is the difference between the Aid flow from UN agencies (US$) in Lesotho and Aid flow from UN agencies (US$) in Syrian Arab Republic?
Give a very brief answer. 2.61e+06. In the year 2003, what is the difference between the Aid flow from UN agencies (US$) of Small states and Aid flow from UN agencies (US$) of Ecuador?
Keep it short and to the point. 1.09e+07. In the year 2003, what is the difference between the Aid flow from UN agencies (US$) of Small states and Aid flow from UN agencies (US$) of Lesotho?
Give a very brief answer. 1.04e+07. In the year 2003, what is the difference between the Aid flow from UN agencies (US$) in Small states and Aid flow from UN agencies (US$) in Syrian Arab Republic?
Ensure brevity in your answer.  1.17e+07. In the year 2003, what is the difference between the Aid flow from UN agencies (US$) of Ecuador and Aid flow from UN agencies (US$) of Lesotho?
Provide a short and direct response. -5.10e+05. In the year 2003, what is the difference between the Aid flow from UN agencies (US$) of Ecuador and Aid flow from UN agencies (US$) of Syrian Arab Republic?
Ensure brevity in your answer.  8.70e+05. In the year 2003, what is the difference between the Aid flow from UN agencies (US$) in Lesotho and Aid flow from UN agencies (US$) in Syrian Arab Republic?
Give a very brief answer. 1.38e+06. What is the ratio of the Aid flow from UN agencies (US$) of Small states in 1997 to that in 1998?
Your response must be concise. 1.65. What is the ratio of the Aid flow from UN agencies (US$) in Ecuador in 1997 to that in 1998?
Offer a terse response. 0.56. What is the ratio of the Aid flow from UN agencies (US$) of Lesotho in 1997 to that in 1998?
Provide a short and direct response. 1.57. What is the ratio of the Aid flow from UN agencies (US$) in Syrian Arab Republic in 1997 to that in 1998?
Offer a very short reply. 1.86. What is the ratio of the Aid flow from UN agencies (US$) in Small states in 1997 to that in 1999?
Ensure brevity in your answer.  1.87. What is the ratio of the Aid flow from UN agencies (US$) in Ecuador in 1997 to that in 1999?
Your answer should be compact. 0.65. What is the ratio of the Aid flow from UN agencies (US$) of Lesotho in 1997 to that in 1999?
Provide a succinct answer. 2.3. What is the ratio of the Aid flow from UN agencies (US$) in Syrian Arab Republic in 1997 to that in 1999?
Ensure brevity in your answer.  1.59. What is the ratio of the Aid flow from UN agencies (US$) in Small states in 1997 to that in 2000?
Provide a succinct answer. 2.13. What is the ratio of the Aid flow from UN agencies (US$) in Ecuador in 1997 to that in 2000?
Give a very brief answer. 0.87. What is the ratio of the Aid flow from UN agencies (US$) in Lesotho in 1997 to that in 2000?
Keep it short and to the point. 2.56. What is the ratio of the Aid flow from UN agencies (US$) in Syrian Arab Republic in 1997 to that in 2000?
Your response must be concise. 2.19. What is the ratio of the Aid flow from UN agencies (US$) of Small states in 1997 to that in 2001?
Ensure brevity in your answer.  2.21. What is the ratio of the Aid flow from UN agencies (US$) in Ecuador in 1997 to that in 2001?
Keep it short and to the point. 0.87. What is the ratio of the Aid flow from UN agencies (US$) of Lesotho in 1997 to that in 2001?
Make the answer very short. 3.18. What is the ratio of the Aid flow from UN agencies (US$) of Syrian Arab Republic in 1997 to that in 2001?
Offer a terse response. 4.16. What is the ratio of the Aid flow from UN agencies (US$) of Small states in 1997 to that in 2002?
Ensure brevity in your answer.  1.15. What is the ratio of the Aid flow from UN agencies (US$) of Ecuador in 1997 to that in 2002?
Provide a succinct answer. 1.33. What is the ratio of the Aid flow from UN agencies (US$) of Lesotho in 1997 to that in 2002?
Keep it short and to the point. 0.91. What is the ratio of the Aid flow from UN agencies (US$) of Syrian Arab Republic in 1997 to that in 2002?
Provide a succinct answer. 11.47. What is the ratio of the Aid flow from UN agencies (US$) of Small states in 1997 to that in 2003?
Keep it short and to the point. 1.34. What is the ratio of the Aid flow from UN agencies (US$) in Ecuador in 1997 to that in 2003?
Ensure brevity in your answer.  1.04. What is the ratio of the Aid flow from UN agencies (US$) in Lesotho in 1997 to that in 2003?
Your response must be concise. 1.31. What is the ratio of the Aid flow from UN agencies (US$) in Syrian Arab Republic in 1997 to that in 2003?
Ensure brevity in your answer.  9.6. What is the ratio of the Aid flow from UN agencies (US$) in Small states in 1998 to that in 1999?
Your response must be concise. 1.13. What is the ratio of the Aid flow from UN agencies (US$) in Ecuador in 1998 to that in 1999?
Offer a very short reply. 1.16. What is the ratio of the Aid flow from UN agencies (US$) of Lesotho in 1998 to that in 1999?
Offer a very short reply. 1.46. What is the ratio of the Aid flow from UN agencies (US$) of Syrian Arab Republic in 1998 to that in 1999?
Your answer should be compact. 0.86. What is the ratio of the Aid flow from UN agencies (US$) of Small states in 1998 to that in 2000?
Provide a succinct answer. 1.29. What is the ratio of the Aid flow from UN agencies (US$) of Ecuador in 1998 to that in 2000?
Your response must be concise. 1.56. What is the ratio of the Aid flow from UN agencies (US$) in Lesotho in 1998 to that in 2000?
Ensure brevity in your answer.  1.63. What is the ratio of the Aid flow from UN agencies (US$) in Syrian Arab Republic in 1998 to that in 2000?
Your answer should be compact. 1.18. What is the ratio of the Aid flow from UN agencies (US$) of Small states in 1998 to that in 2001?
Offer a very short reply. 1.34. What is the ratio of the Aid flow from UN agencies (US$) of Ecuador in 1998 to that in 2001?
Keep it short and to the point. 1.56. What is the ratio of the Aid flow from UN agencies (US$) in Lesotho in 1998 to that in 2001?
Your answer should be compact. 2.02. What is the ratio of the Aid flow from UN agencies (US$) in Syrian Arab Republic in 1998 to that in 2001?
Give a very brief answer. 2.24. What is the ratio of the Aid flow from UN agencies (US$) in Small states in 1998 to that in 2002?
Ensure brevity in your answer.  0.7. What is the ratio of the Aid flow from UN agencies (US$) of Ecuador in 1998 to that in 2002?
Give a very brief answer. 2.38. What is the ratio of the Aid flow from UN agencies (US$) in Lesotho in 1998 to that in 2002?
Your answer should be very brief. 0.58. What is the ratio of the Aid flow from UN agencies (US$) of Syrian Arab Republic in 1998 to that in 2002?
Your answer should be very brief. 6.17. What is the ratio of the Aid flow from UN agencies (US$) in Small states in 1998 to that in 2003?
Provide a succinct answer. 0.81. What is the ratio of the Aid flow from UN agencies (US$) of Ecuador in 1998 to that in 2003?
Offer a very short reply. 1.86. What is the ratio of the Aid flow from UN agencies (US$) in Lesotho in 1998 to that in 2003?
Offer a very short reply. 0.83. What is the ratio of the Aid flow from UN agencies (US$) of Syrian Arab Republic in 1998 to that in 2003?
Keep it short and to the point. 5.16. What is the ratio of the Aid flow from UN agencies (US$) of Small states in 1999 to that in 2000?
Your answer should be very brief. 1.14. What is the ratio of the Aid flow from UN agencies (US$) in Ecuador in 1999 to that in 2000?
Ensure brevity in your answer.  1.34. What is the ratio of the Aid flow from UN agencies (US$) of Lesotho in 1999 to that in 2000?
Offer a very short reply. 1.11. What is the ratio of the Aid flow from UN agencies (US$) in Syrian Arab Republic in 1999 to that in 2000?
Provide a short and direct response. 1.38. What is the ratio of the Aid flow from UN agencies (US$) of Small states in 1999 to that in 2001?
Ensure brevity in your answer.  1.18. What is the ratio of the Aid flow from UN agencies (US$) in Ecuador in 1999 to that in 2001?
Offer a very short reply. 1.34. What is the ratio of the Aid flow from UN agencies (US$) in Lesotho in 1999 to that in 2001?
Your response must be concise. 1.38. What is the ratio of the Aid flow from UN agencies (US$) in Syrian Arab Republic in 1999 to that in 2001?
Your answer should be compact. 2.61. What is the ratio of the Aid flow from UN agencies (US$) in Small states in 1999 to that in 2002?
Provide a succinct answer. 0.62. What is the ratio of the Aid flow from UN agencies (US$) in Ecuador in 1999 to that in 2002?
Your answer should be compact. 2.05. What is the ratio of the Aid flow from UN agencies (US$) in Lesotho in 1999 to that in 2002?
Your answer should be compact. 0.4. What is the ratio of the Aid flow from UN agencies (US$) in Syrian Arab Republic in 1999 to that in 2002?
Your answer should be very brief. 7.21. What is the ratio of the Aid flow from UN agencies (US$) of Small states in 1999 to that in 2003?
Give a very brief answer. 0.71. What is the ratio of the Aid flow from UN agencies (US$) of Ecuador in 1999 to that in 2003?
Your answer should be compact. 1.6. What is the ratio of the Aid flow from UN agencies (US$) of Lesotho in 1999 to that in 2003?
Keep it short and to the point. 0.57. What is the ratio of the Aid flow from UN agencies (US$) of Syrian Arab Republic in 1999 to that in 2003?
Offer a terse response. 6.03. What is the ratio of the Aid flow from UN agencies (US$) in Small states in 2000 to that in 2001?
Provide a short and direct response. 1.04. What is the ratio of the Aid flow from UN agencies (US$) in Lesotho in 2000 to that in 2001?
Provide a short and direct response. 1.24. What is the ratio of the Aid flow from UN agencies (US$) in Syrian Arab Republic in 2000 to that in 2001?
Provide a short and direct response. 1.9. What is the ratio of the Aid flow from UN agencies (US$) of Small states in 2000 to that in 2002?
Keep it short and to the point. 0.54. What is the ratio of the Aid flow from UN agencies (US$) of Ecuador in 2000 to that in 2002?
Provide a succinct answer. 1.53. What is the ratio of the Aid flow from UN agencies (US$) of Lesotho in 2000 to that in 2002?
Provide a succinct answer. 0.36. What is the ratio of the Aid flow from UN agencies (US$) in Syrian Arab Republic in 2000 to that in 2002?
Your answer should be very brief. 5.24. What is the ratio of the Aid flow from UN agencies (US$) of Small states in 2000 to that in 2003?
Offer a terse response. 0.63. What is the ratio of the Aid flow from UN agencies (US$) in Ecuador in 2000 to that in 2003?
Offer a terse response. 1.19. What is the ratio of the Aid flow from UN agencies (US$) in Lesotho in 2000 to that in 2003?
Offer a terse response. 0.51. What is the ratio of the Aid flow from UN agencies (US$) of Syrian Arab Republic in 2000 to that in 2003?
Your answer should be very brief. 4.38. What is the ratio of the Aid flow from UN agencies (US$) of Small states in 2001 to that in 2002?
Offer a terse response. 0.52. What is the ratio of the Aid flow from UN agencies (US$) of Ecuador in 2001 to that in 2002?
Provide a short and direct response. 1.53. What is the ratio of the Aid flow from UN agencies (US$) of Lesotho in 2001 to that in 2002?
Offer a very short reply. 0.29. What is the ratio of the Aid flow from UN agencies (US$) in Syrian Arab Republic in 2001 to that in 2002?
Provide a succinct answer. 2.76. What is the ratio of the Aid flow from UN agencies (US$) of Small states in 2001 to that in 2003?
Offer a very short reply. 0.6. What is the ratio of the Aid flow from UN agencies (US$) of Ecuador in 2001 to that in 2003?
Give a very brief answer. 1.19. What is the ratio of the Aid flow from UN agencies (US$) of Lesotho in 2001 to that in 2003?
Your answer should be compact. 0.41. What is the ratio of the Aid flow from UN agencies (US$) in Syrian Arab Republic in 2001 to that in 2003?
Your response must be concise. 2.31. What is the ratio of the Aid flow from UN agencies (US$) of Small states in 2002 to that in 2003?
Give a very brief answer. 1.16. What is the ratio of the Aid flow from UN agencies (US$) in Ecuador in 2002 to that in 2003?
Your answer should be very brief. 0.78. What is the ratio of the Aid flow from UN agencies (US$) of Lesotho in 2002 to that in 2003?
Make the answer very short. 1.44. What is the ratio of the Aid flow from UN agencies (US$) of Syrian Arab Republic in 2002 to that in 2003?
Your response must be concise. 0.84. What is the difference between the highest and the second highest Aid flow from UN agencies (US$) in Small states?
Your answer should be compact. 2.28e+06. What is the difference between the highest and the second highest Aid flow from UN agencies (US$) of Ecuador?
Give a very brief answer. 5.00e+05. What is the difference between the highest and the second highest Aid flow from UN agencies (US$) of Lesotho?
Keep it short and to the point. 3.00e+05. What is the difference between the highest and the second highest Aid flow from UN agencies (US$) of Syrian Arab Republic?
Ensure brevity in your answer.  3.71e+06. What is the difference between the highest and the lowest Aid flow from UN agencies (US$) of Small states?
Ensure brevity in your answer.  9.35e+06. What is the difference between the highest and the lowest Aid flow from UN agencies (US$) in Ecuador?
Your response must be concise. 2.06e+06. What is the difference between the highest and the lowest Aid flow from UN agencies (US$) of Lesotho?
Ensure brevity in your answer.  2.48e+06. What is the difference between the highest and the lowest Aid flow from UN agencies (US$) in Syrian Arab Republic?
Your answer should be compact. 9.11e+06. 